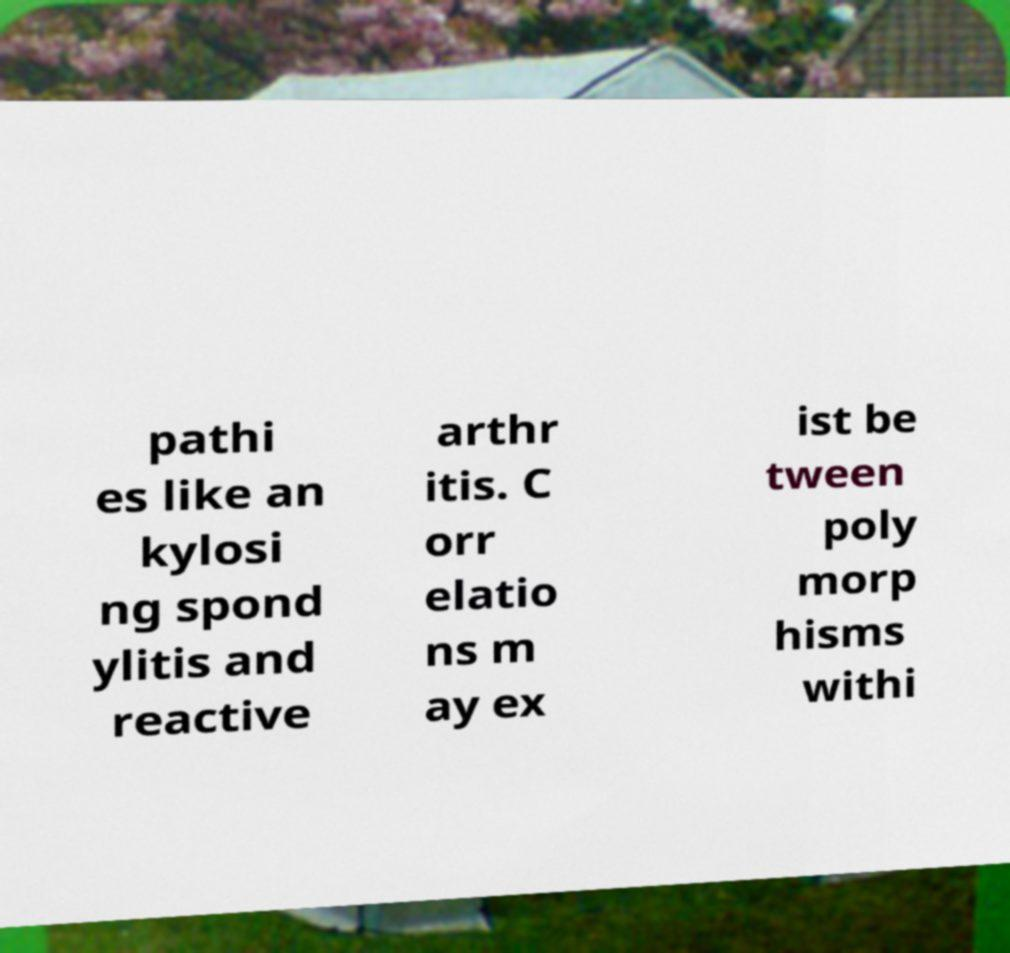I need the written content from this picture converted into text. Can you do that? pathi es like an kylosi ng spond ylitis and reactive arthr itis. C orr elatio ns m ay ex ist be tween poly morp hisms withi 